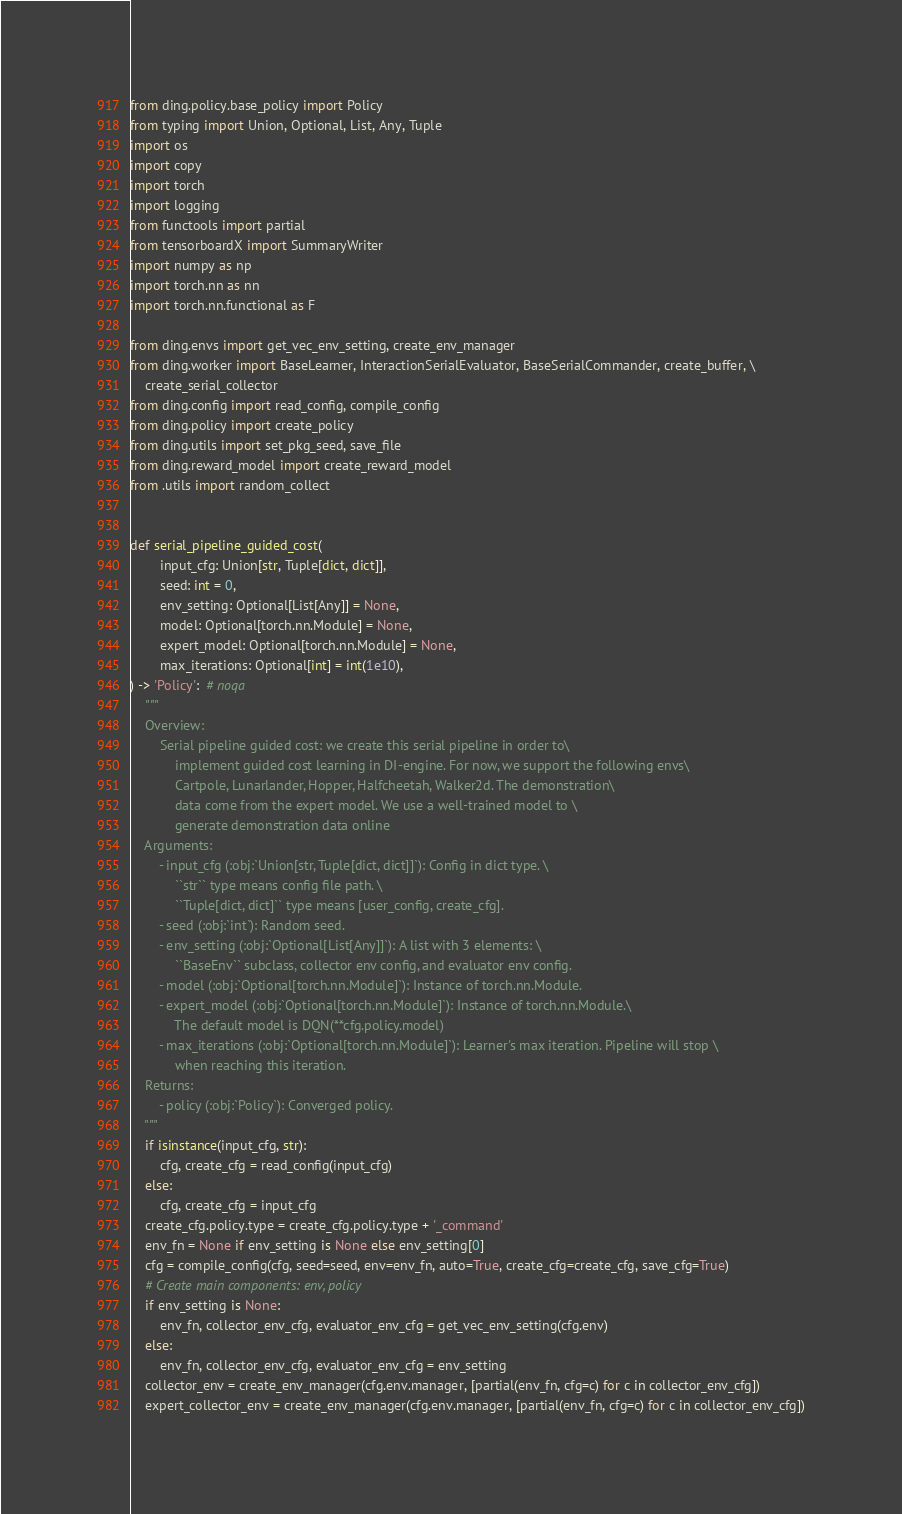Convert code to text. <code><loc_0><loc_0><loc_500><loc_500><_Python_>from ding.policy.base_policy import Policy
from typing import Union, Optional, List, Any, Tuple
import os
import copy
import torch
import logging
from functools import partial
from tensorboardX import SummaryWriter
import numpy as np
import torch.nn as nn
import torch.nn.functional as F

from ding.envs import get_vec_env_setting, create_env_manager
from ding.worker import BaseLearner, InteractionSerialEvaluator, BaseSerialCommander, create_buffer, \
    create_serial_collector
from ding.config import read_config, compile_config
from ding.policy import create_policy
from ding.utils import set_pkg_seed, save_file
from ding.reward_model import create_reward_model
from .utils import random_collect


def serial_pipeline_guided_cost(
        input_cfg: Union[str, Tuple[dict, dict]],
        seed: int = 0,
        env_setting: Optional[List[Any]] = None,
        model: Optional[torch.nn.Module] = None,
        expert_model: Optional[torch.nn.Module] = None,
        max_iterations: Optional[int] = int(1e10),
) -> 'Policy':  # noqa
    """
    Overview:
        Serial pipeline guided cost: we create this serial pipeline in order to\
            implement guided cost learning in DI-engine. For now, we support the following envs\
            Cartpole, Lunarlander, Hopper, Halfcheetah, Walker2d. The demonstration\
            data come from the expert model. We use a well-trained model to \
            generate demonstration data online
    Arguments:
        - input_cfg (:obj:`Union[str, Tuple[dict, dict]]`): Config in dict type. \
            ``str`` type means config file path. \
            ``Tuple[dict, dict]`` type means [user_config, create_cfg].
        - seed (:obj:`int`): Random seed.
        - env_setting (:obj:`Optional[List[Any]]`): A list with 3 elements: \
            ``BaseEnv`` subclass, collector env config, and evaluator env config.
        - model (:obj:`Optional[torch.nn.Module]`): Instance of torch.nn.Module.
        - expert_model (:obj:`Optional[torch.nn.Module]`): Instance of torch.nn.Module.\
            The default model is DQN(**cfg.policy.model)
        - max_iterations (:obj:`Optional[torch.nn.Module]`): Learner's max iteration. Pipeline will stop \
            when reaching this iteration.
    Returns:
        - policy (:obj:`Policy`): Converged policy.
    """
    if isinstance(input_cfg, str):
        cfg, create_cfg = read_config(input_cfg)
    else:
        cfg, create_cfg = input_cfg
    create_cfg.policy.type = create_cfg.policy.type + '_command'
    env_fn = None if env_setting is None else env_setting[0]
    cfg = compile_config(cfg, seed=seed, env=env_fn, auto=True, create_cfg=create_cfg, save_cfg=True)
    # Create main components: env, policy
    if env_setting is None:
        env_fn, collector_env_cfg, evaluator_env_cfg = get_vec_env_setting(cfg.env)
    else:
        env_fn, collector_env_cfg, evaluator_env_cfg = env_setting
    collector_env = create_env_manager(cfg.env.manager, [partial(env_fn, cfg=c) for c in collector_env_cfg])
    expert_collector_env = create_env_manager(cfg.env.manager, [partial(env_fn, cfg=c) for c in collector_env_cfg])</code> 